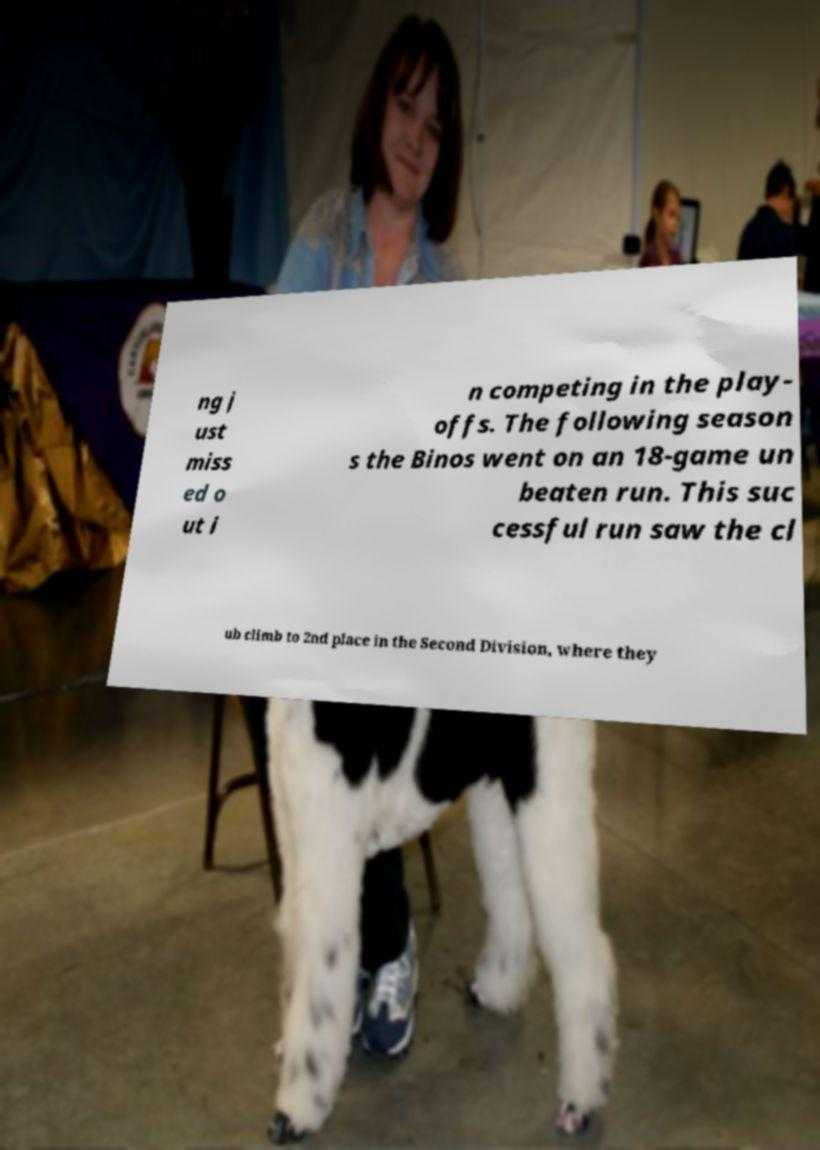Could you assist in decoding the text presented in this image and type it out clearly? ng j ust miss ed o ut i n competing in the play- offs. The following season s the Binos went on an 18-game un beaten run. This suc cessful run saw the cl ub climb to 2nd place in the Second Division, where they 